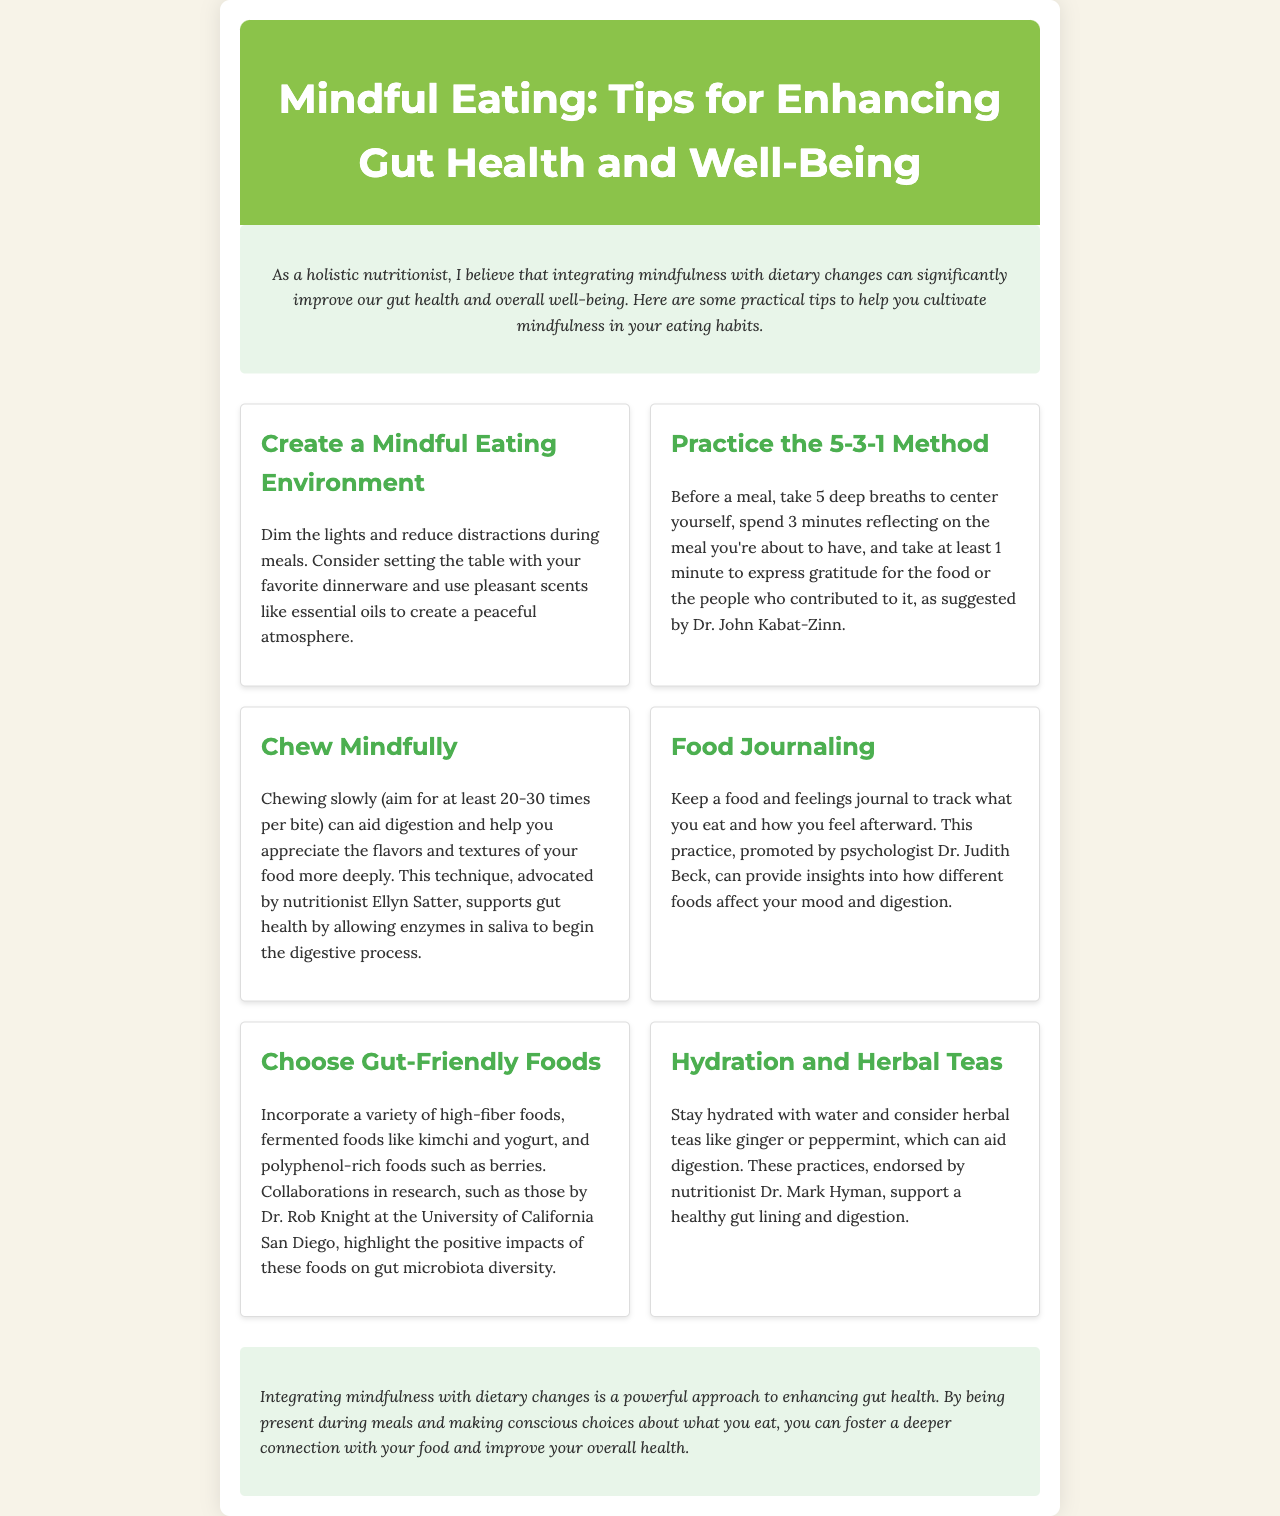What is the title of the newsletter? The title is the main heading of the document and can be found at the top.
Answer: Mindful Eating: Tips for Enhancing Gut Health and Well-Being Who is the author of the newsletter? The author is mentioned at the beginning of the document.
Answer: A holistic nutritionist What method involves taking deep breaths before a meal? The method is specified in one of the tips for enhancing mindfulness during meals.
Answer: 5-3-1 Method How many times should you aim to chew per bite? This number is suggested in the tip about chewing mindfully.
Answer: 20-30 Which foods should you incorporate for gut health? The specific types of foods are listed in the tips section.
Answer: High-fiber foods, fermented foods, polyphenol-rich foods What is recommended to stay hydrated? This information can be found in the hydration section of the tips.
Answer: Water and herbal teas In what way does food journaling help? The purpose of food journaling is explained in the document.
Answer: Provides insights into how different foods affect your mood and digestion What type of environment should you create for mindful eating? This is addressed in one of the tips provided in the newsletter.
Answer: A peaceful atmosphere Which researcher is mentioned regarding gut microbiota diversity? The researcher is referenced in the tip on choosing gut-friendly foods.
Answer: Dr. Rob Knight 